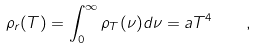<formula> <loc_0><loc_0><loc_500><loc_500>\rho _ { r } ( T ) = \int _ { 0 } ^ { \infty } \rho _ { T } ( \nu ) d \nu = a T ^ { 4 } \quad ,</formula> 